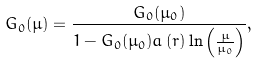Convert formula to latex. <formula><loc_0><loc_0><loc_500><loc_500>G _ { 0 } ( \mu ) = \frac { G _ { 0 } ( \mu _ { 0 } ) } { 1 - G _ { 0 } ( \mu _ { 0 } ) a \left ( r \right ) \ln \left ( \frac { \mu } { \mu _ { 0 } } \right ) } ,</formula> 